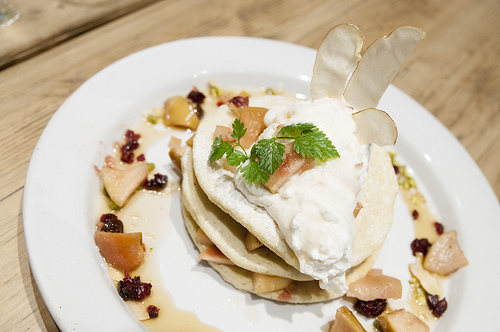<image>
Is the egg on the plate? Yes. Looking at the image, I can see the egg is positioned on top of the plate, with the plate providing support. 